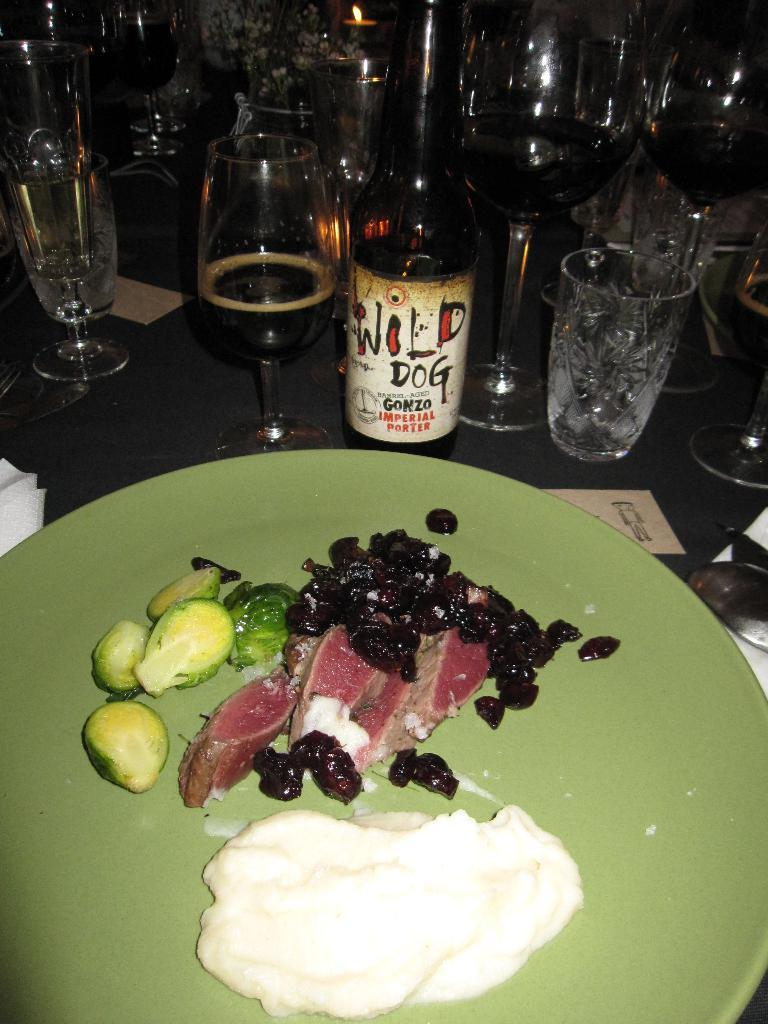What piece of furniture is present in the image? There is a table in the image. What items are placed on the table? There are glasses, a wine bottle, and a plate with food served on the table. Where is the nest located in the image? There is no nest present in the image. What type of addition is being made to the table in the image? There is no indication of an addition being made to the table in the image. 